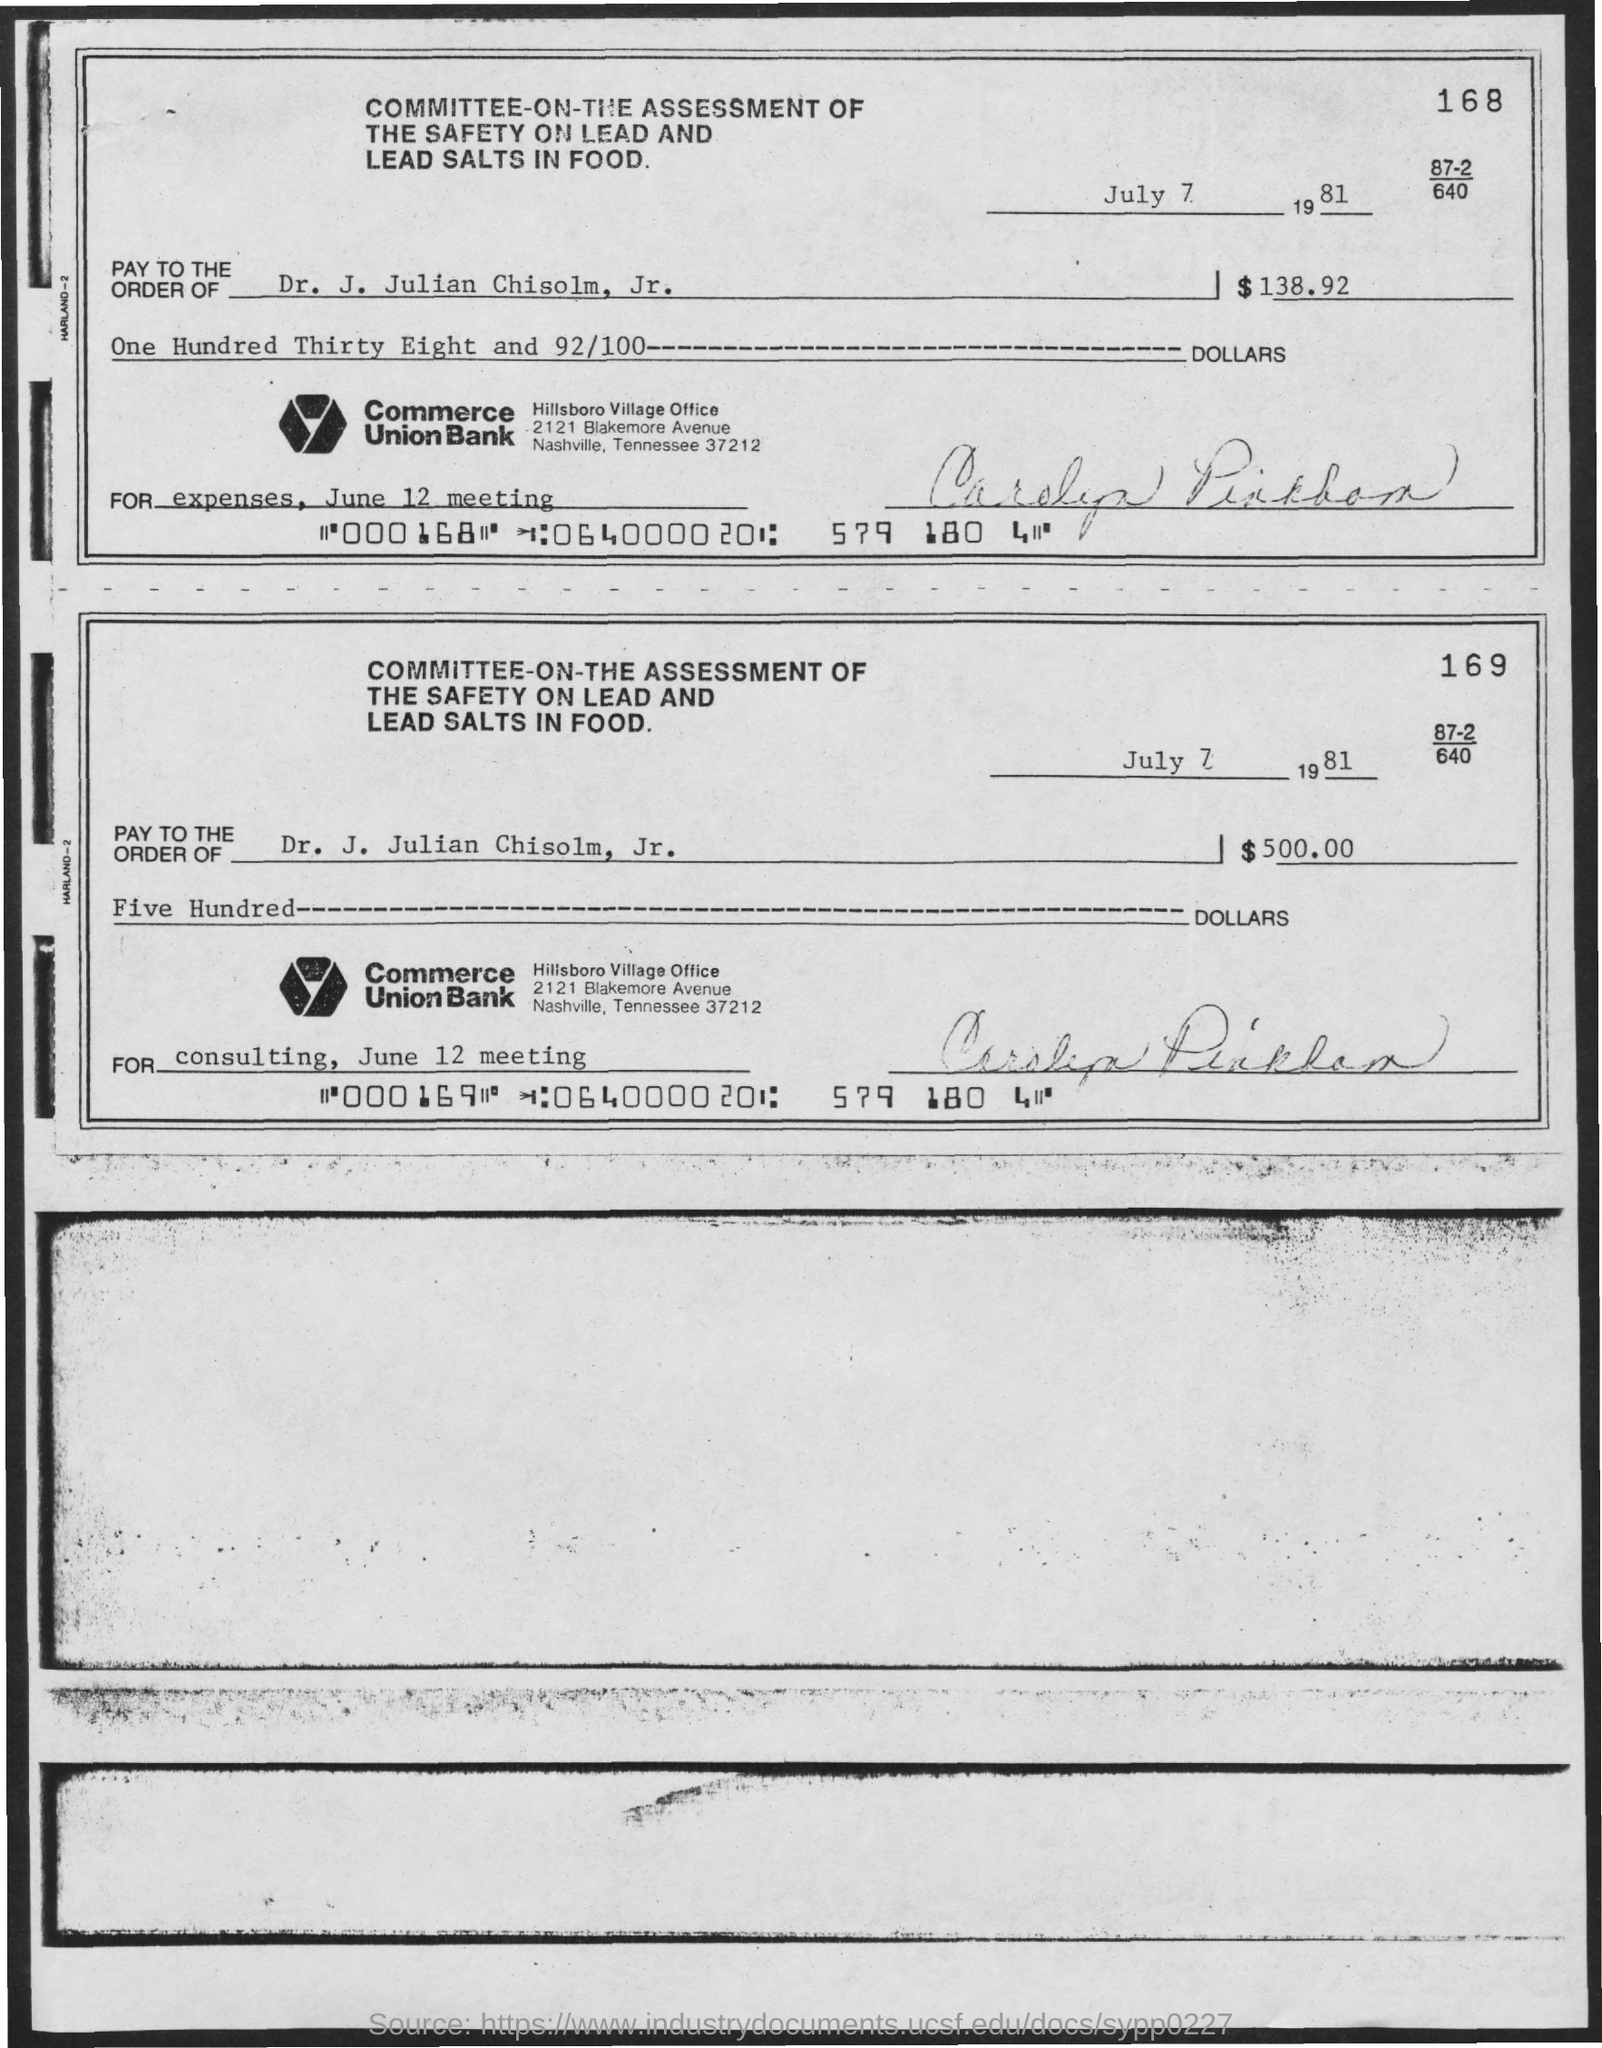Specify some key components in this picture. The individual responsible for issuing checks should pay them to Dr. J. Julian Chisolm, Jr. The amount for consulting on June 12 is $500 in dollars. The document is dated July 7th, 1981. The amount specified on Check 168 is $138.92 in dollars. 